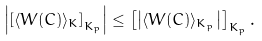Convert formula to latex. <formula><loc_0><loc_0><loc_500><loc_500>\left | \left [ \langle W ( C ) \rangle _ { K } \right ] _ { K _ { p } } \right | \leq \left [ \left | \langle W ( C ) \rangle _ { K _ { p } } \right | \right ] _ { K _ { p } } .</formula> 